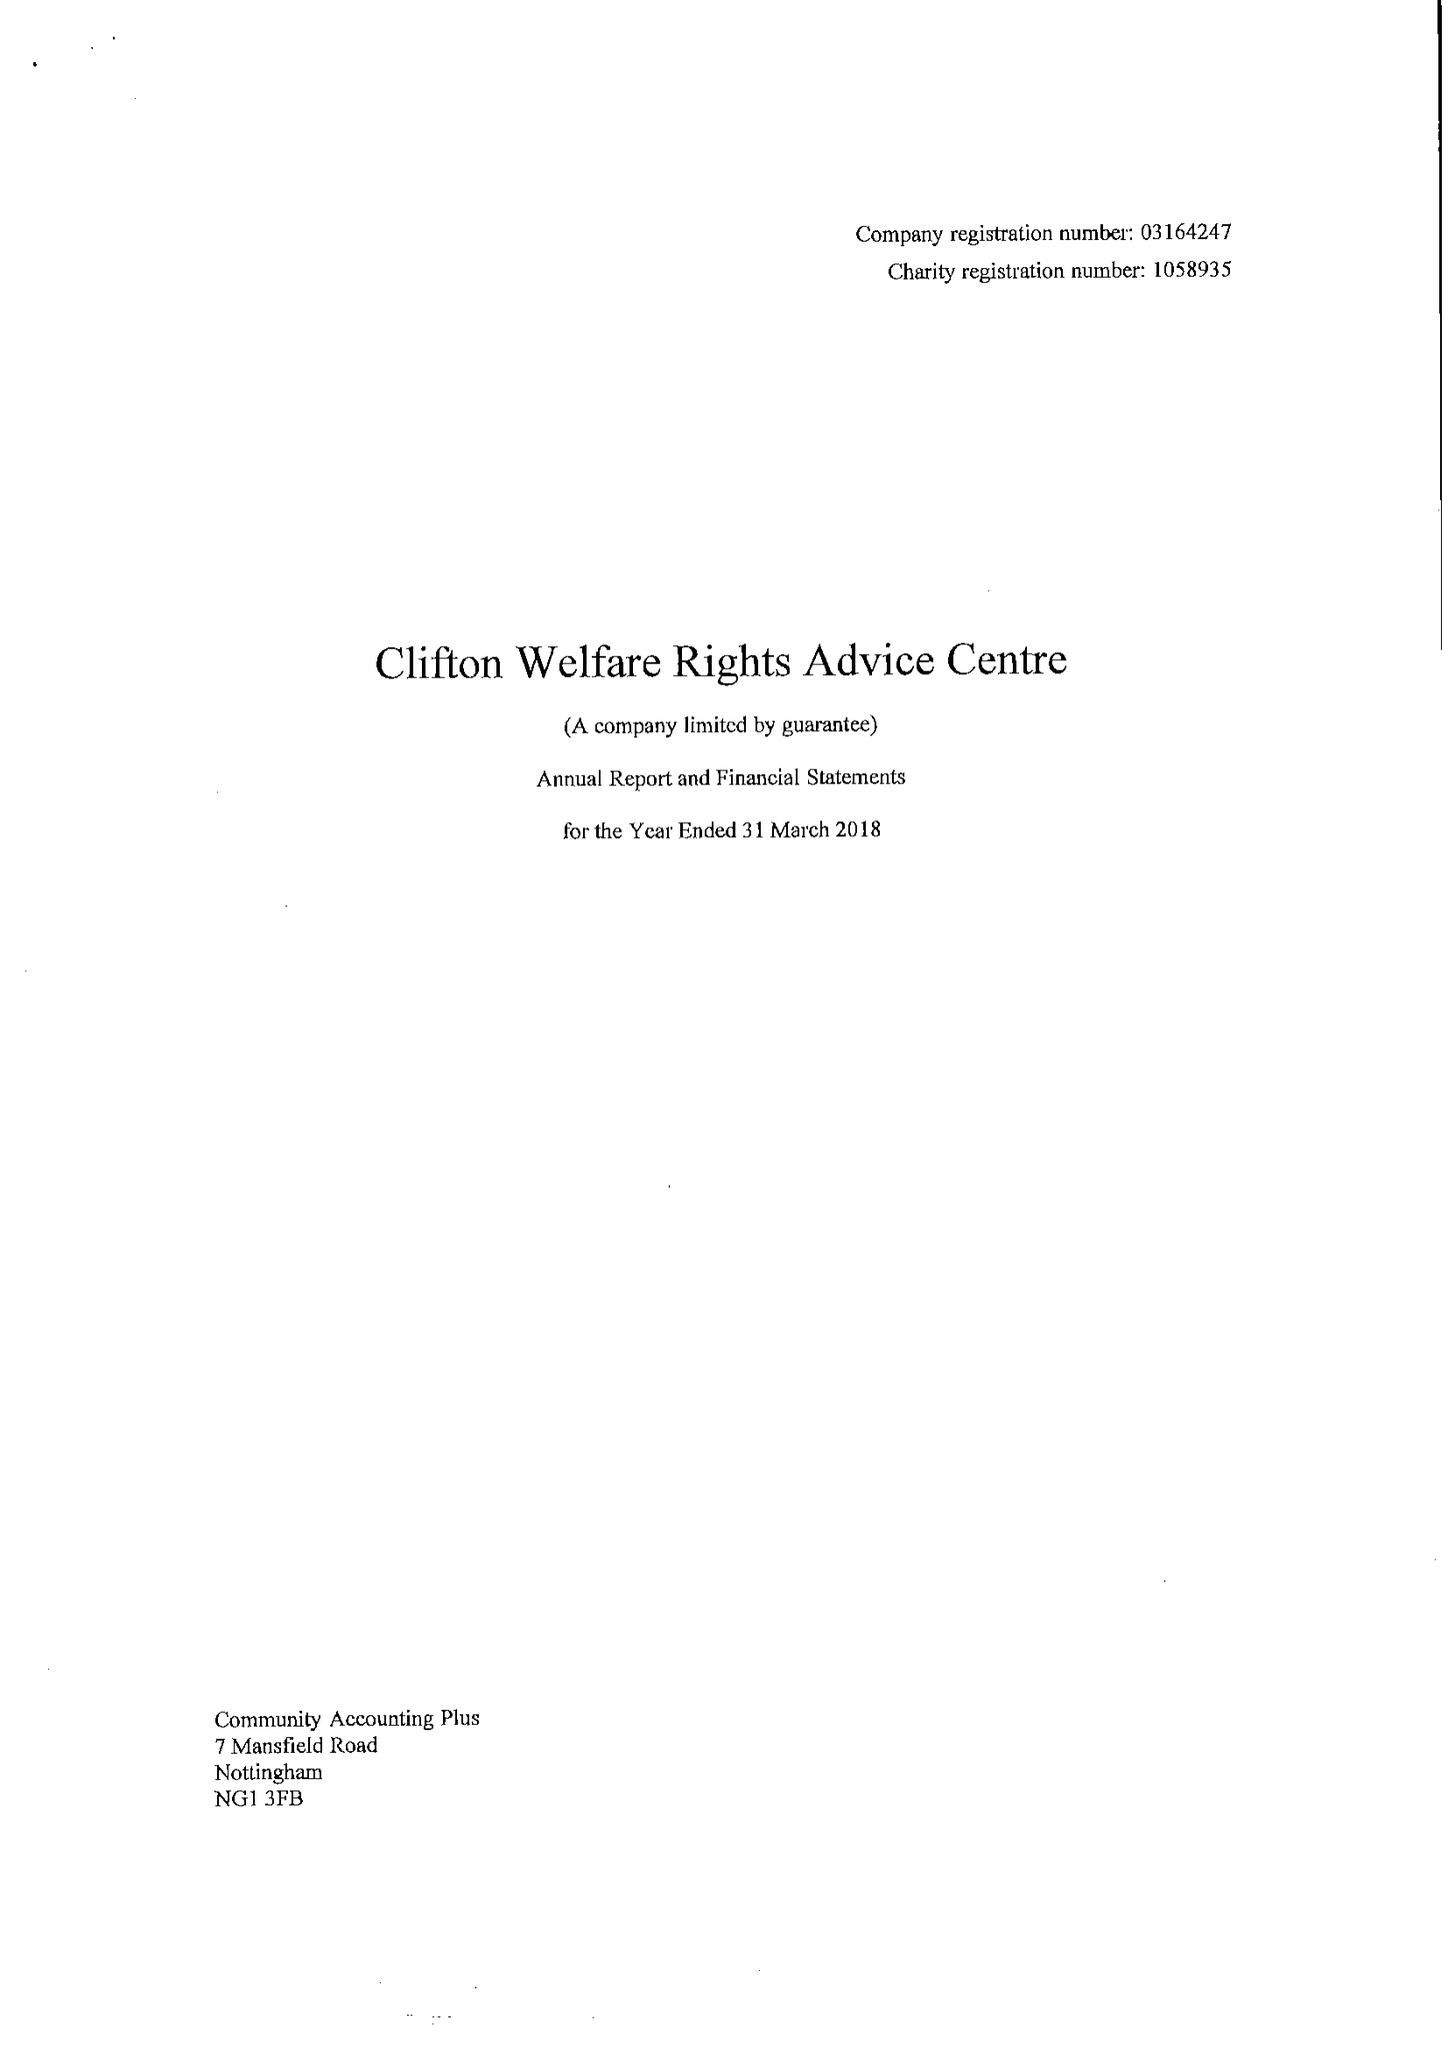What is the value for the address__postcode?
Answer the question using a single word or phrase. NG11 8EW 